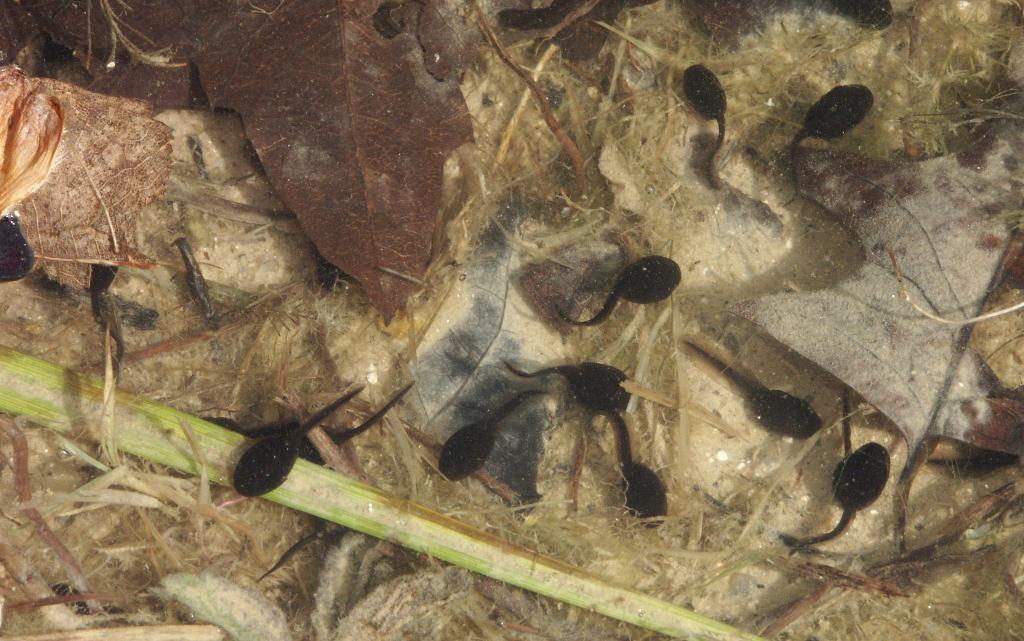How would you summarize this image in a sentence or two? In this image we can see group of insects and some dried leaves on the floor. 